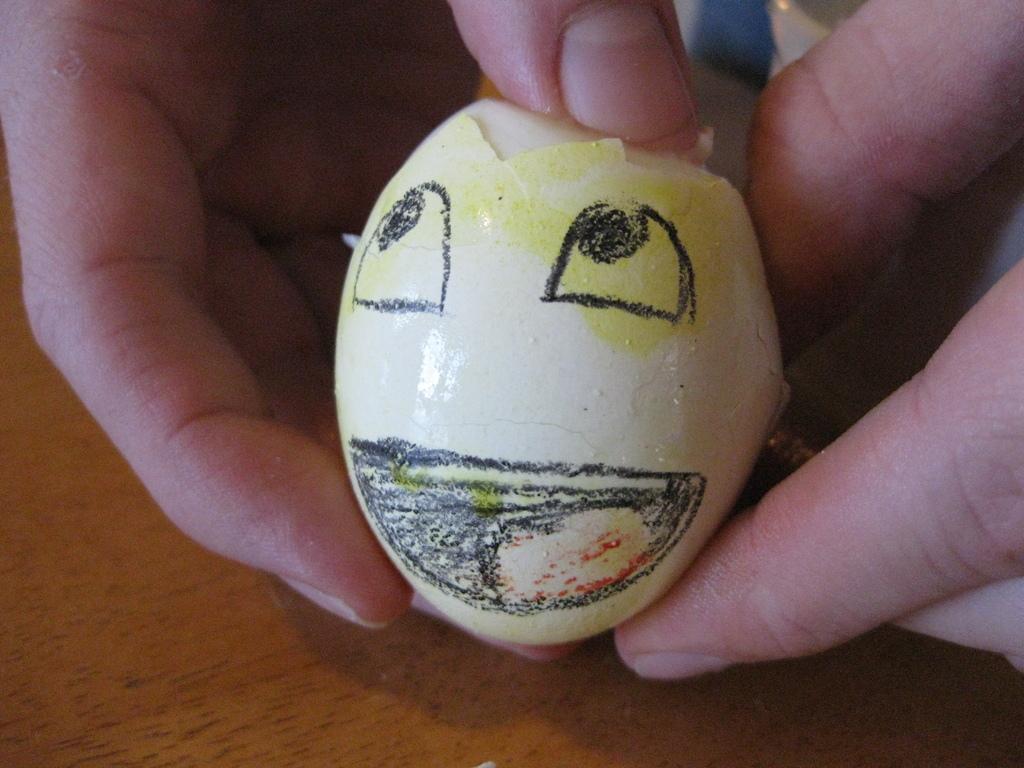Can you describe this image briefly? In the picture we can see a person's hand holding an egg with an art on the egg shell. Here we can see the wooden surface. 